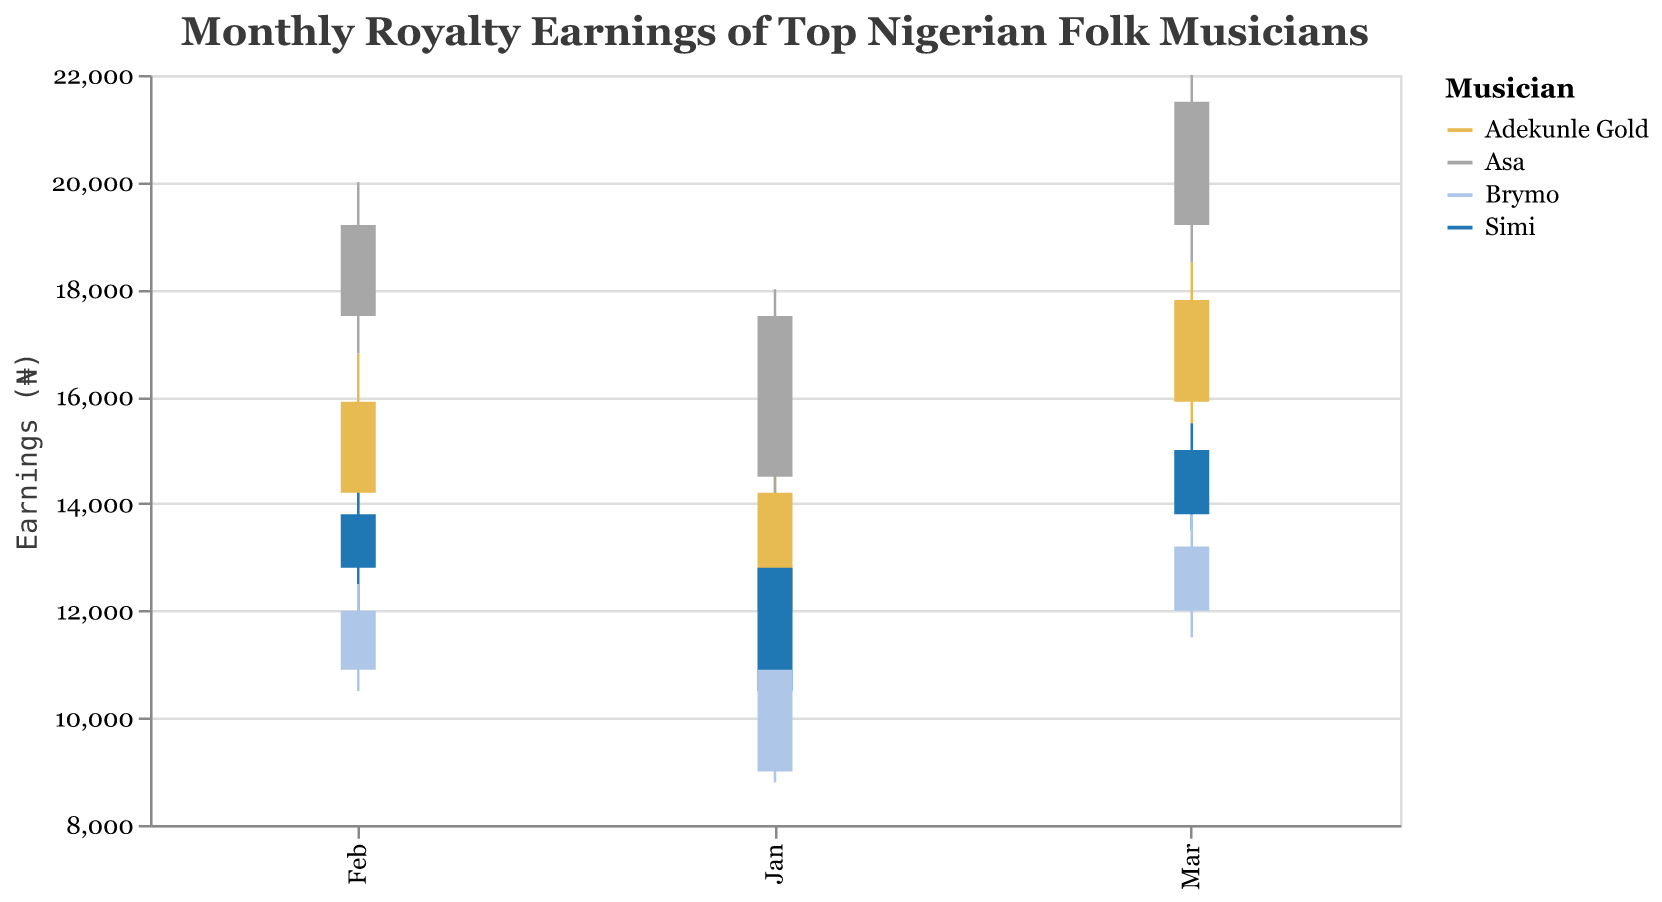What is the title of the chart? The title of the chart is located at the top of the figure. It summarizes what the chart is about.
Answer: Monthly Royalty Earnings of Top Nigerian Folk Musicians Which musician had the highest 'Close' value in January? In January, looking at the highest 'Close' value for each musician, Asa had the highest 'Close' value at ₦17,500.
Answer: Asa What was the 'Open' value for Simi in February? Examine the 'Open' value corresponding to Simi in February, which is listed as ₦12,800.
Answer: ₦12,800 By how much did Adekunle Gold's 'Close' value increase from January to February? Adekunle Gold's 'Close' value in January is ₦14,200 and in February is ₦15,900. The increase can be calculated by subtracting January's value from February's value: ₦15,900 - ₦14,200 = ₦1,700.
Answer: ₦1,700 Which musician had the smallest difference between 'High' and 'Low' in March? In March, calculate the difference between 'High' and 'Low' for each musician and compare: Adekunle Gold (₦18,500 - ₦15,500 = ₦3,000), Simi (₦15,500 - ₦13,500 = ₦2,000), Brymo (₦13,800 - ₦11,500 = ₦2,300), Asa (₦22,000 - ₦18,500 = ₦3,500). Simi had the smallest difference at ₦2,000.
Answer: Simi What is Brymo's average 'Close' value across all three months? Calculate Brymo's 'Close' values for each month (₦10,900 in January, ₦12,000 in February, and ₦13,200 in March), sum them (₦10,900 + ₦12,000 + ₦13,200 = ₦36,100), and divide by the number of months (₦36,100 / 3).
Answer: ₦12,033.33 Between Adekunle Gold and Asa, who had the higher 'High' value in February? Compare the 'High' values in February for Adekunle Gold (₦16,800) and Asa (₦20,000). Asa had the higher 'High' value.
Answer: Asa What was the difference between Asa's 'Open' and 'Close' values in March? For Asa in March, the 'Open' value is ₦19,200 and the 'Close' value is ₦21,500. The difference is ₦21,500 - ₦19,200 = ₦2,300.
Answer: ₦2,300 Which musician had increasing 'Close' values every month? Examine the 'Close' values for each musician across the months. Adekunle Gold (₦14,200, ₦15,900, ₦17,800) shows an increasing trend in 'Close' values every month.
Answer: Adekunle Gold 